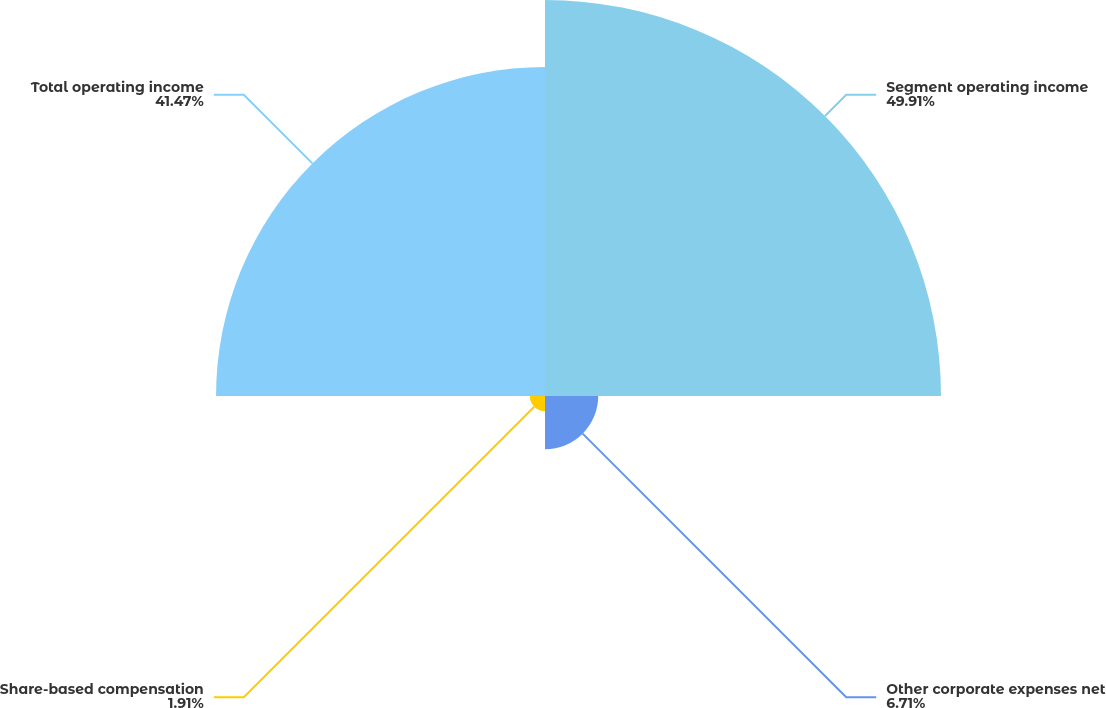Convert chart to OTSL. <chart><loc_0><loc_0><loc_500><loc_500><pie_chart><fcel>Segment operating income<fcel>Other corporate expenses net<fcel>Share-based compensation<fcel>Total operating income<nl><fcel>49.92%<fcel>6.71%<fcel>1.91%<fcel>41.47%<nl></chart> 